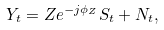Convert formula to latex. <formula><loc_0><loc_0><loc_500><loc_500>Y _ { t } = Z e ^ { - j \phi _ { Z } } S _ { t } + N _ { t } ,</formula> 